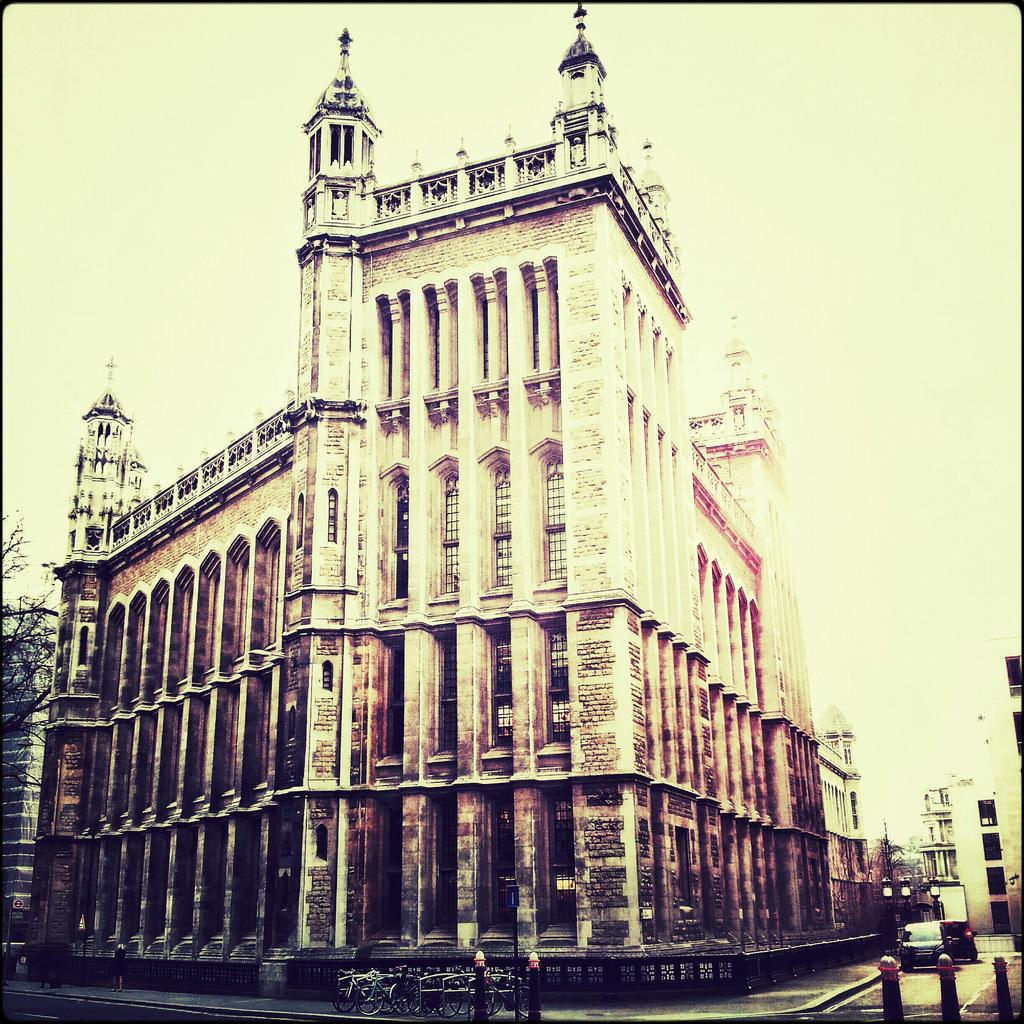What type of structures can be seen in the image? There are buildings in the image. What natural element is present in the image? There is a tree in the image. What are the vertical objects in the image? There are poles in the image. What mode of transportation can be seen in the image? There are bicycles in the image. What type of vehicles are on the road in the image? There are vehicles on the road in the image. What other objects are on the ground in the image? There are other objects on the ground in the image. What can be seen in the background of the image? The sky is visible in the background of the image. How many frogs are sitting on the bicycles in the image? There are no frogs present in the image; it features buildings, a tree, poles, bicycles, vehicles, and other objects on the ground. Can you tell me where the hen is located in the image? There is no hen present in the image. 